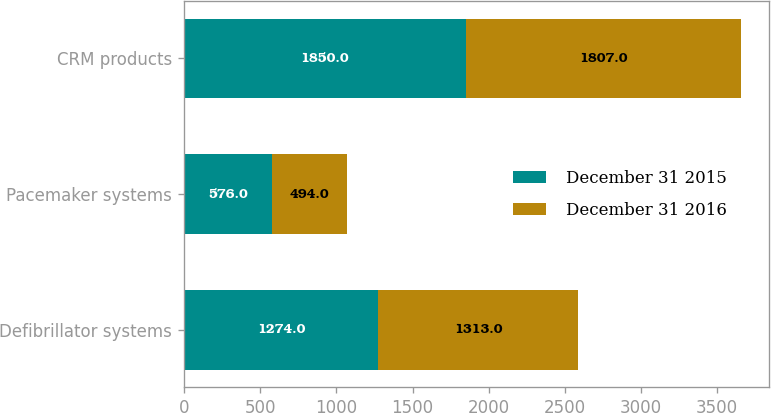<chart> <loc_0><loc_0><loc_500><loc_500><stacked_bar_chart><ecel><fcel>Defibrillator systems<fcel>Pacemaker systems<fcel>CRM products<nl><fcel>December 31 2015<fcel>1274<fcel>576<fcel>1850<nl><fcel>December 31 2016<fcel>1313<fcel>494<fcel>1807<nl></chart> 